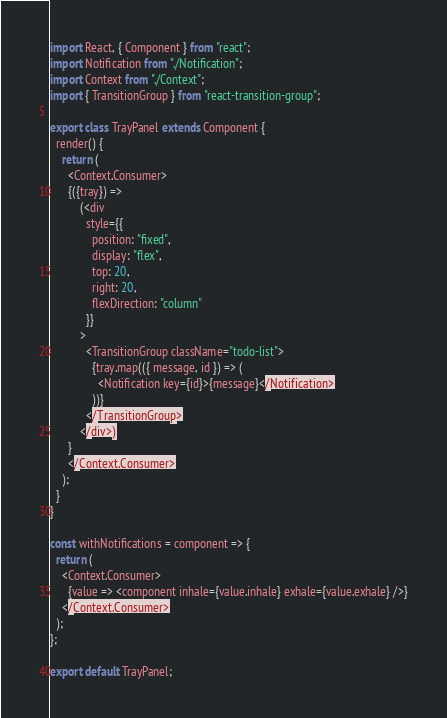Convert code to text. <code><loc_0><loc_0><loc_500><loc_500><_JavaScript_>import React, { Component } from "react";
import Notification from "./Notification";
import Context from "./Context";
import { TransitionGroup } from "react-transition-group";

export class TrayPanel extends Component {
  render() {
    return (
      <Context.Consumer>
      {({tray}) =>
          (<div
            style={{
              position: "fixed",
              display: "flex",
              top: 20,
              right: 20,
              flexDirection: "column"
            }}
          >
            <TransitionGroup className="todo-list">
              {tray.map(({ message, id }) => (
                <Notification key={id}>{message}</Notification>
              ))}
            </TransitionGroup>
          </div>)
      }
      </Context.Consumer>
    );
  }
}

const withNotifications = component => {
  return (
    <Context.Consumer>
      {value => <component inhale={value.inhale} exhale={value.exhale} />}
    </Context.Consumer>
  );
};

export default TrayPanel;
</code> 